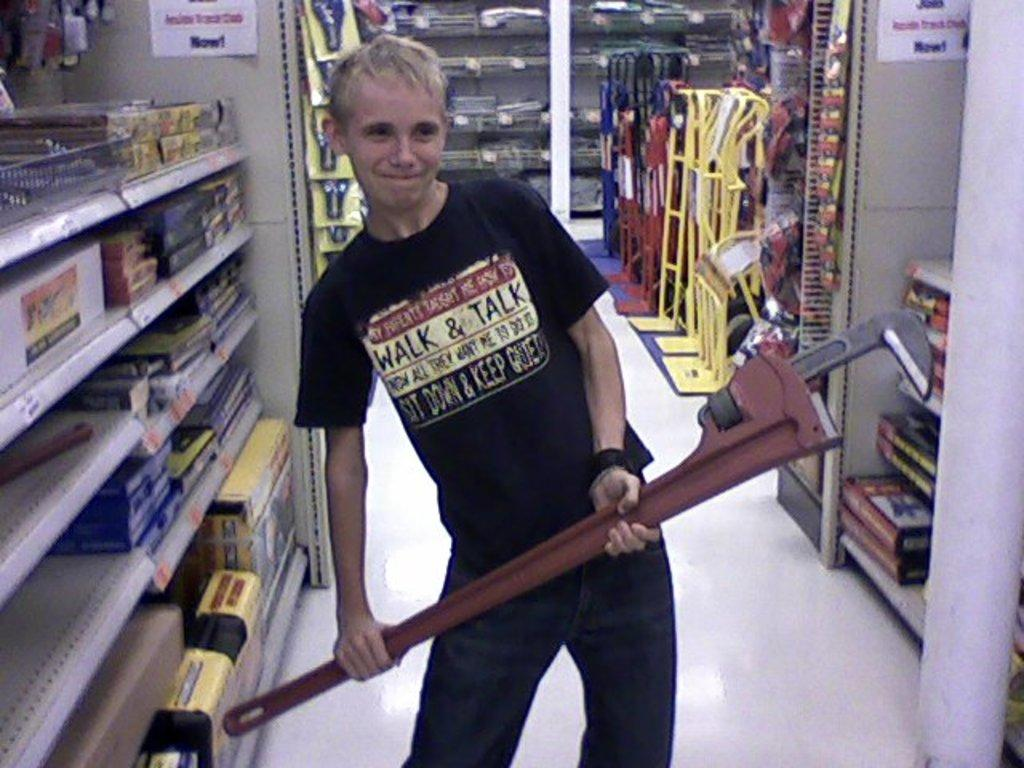<image>
Present a compact description of the photo's key features. A boy holding a large pipe wrench wears a shirt that says "Walk and Talk". 